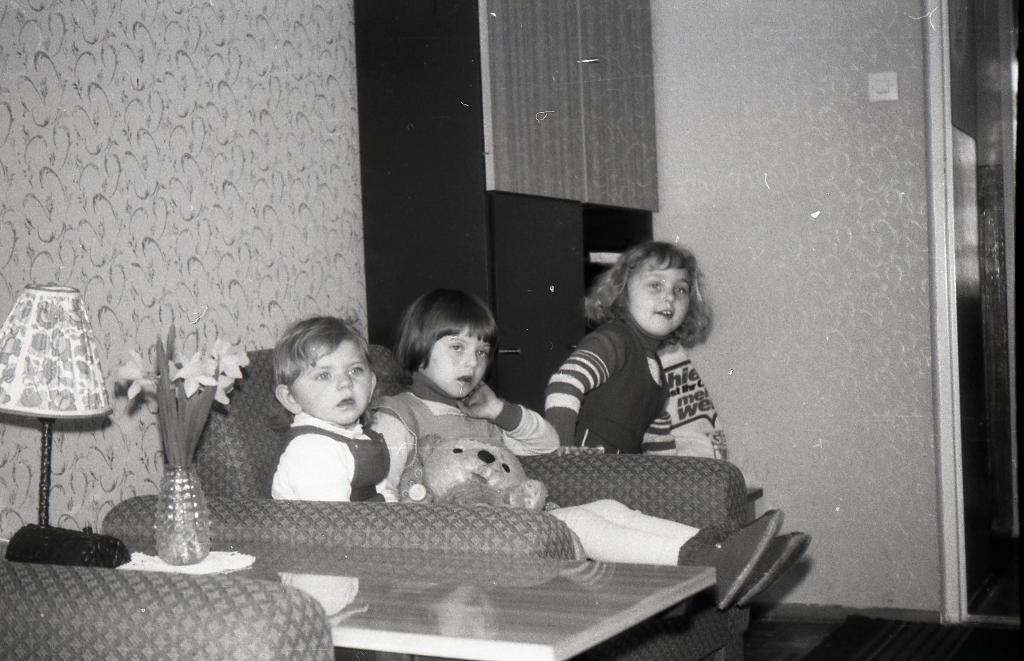How would you summarize this image in a sentence or two? There are three children sitting in this room, two of them were in sofa and the another one is on the stool. There is a lamp and in the background, there is a wall and some cupboards here. 